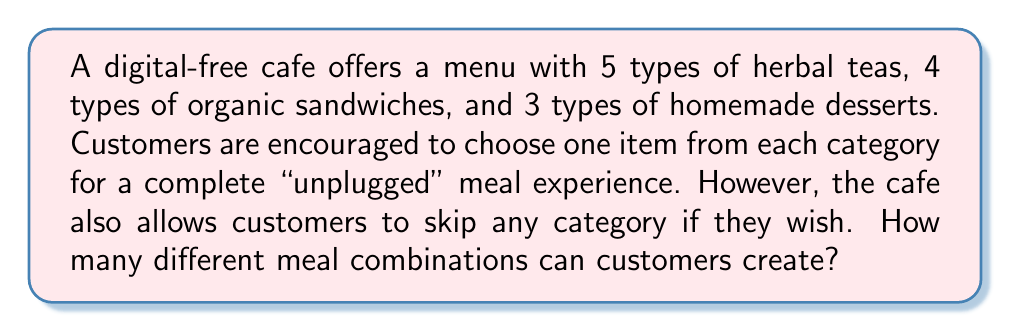What is the answer to this math problem? Let's approach this step-by-step:

1) First, we need to consider the options for each category:
   - Herbal teas: 5 options
   - Organic sandwiches: 4 options
   - Homemade desserts: 3 options

2) For each category, customers have the option to either choose an item or skip it. This means we need to add 1 to each category's count to represent the "skip" option:
   - Herbal teas: 5 + 1 = 6 options (including skip)
   - Organic sandwiches: 4 + 1 = 5 options (including skip)
   - Homemade desserts: 3 + 1 = 4 options (including skip)

3) Now, we can use the multiplication principle. The total number of combinations is the product of the number of options for each category:

   $$ \text{Total combinations} = 6 \times 5 \times 4 $$

4) Calculate:
   $$ 6 \times 5 \times 4 = 120 $$

5) However, we need to subtract 1 from this total. Why? Because the combination where all categories are skipped (no tea, no sandwich, no dessert) is not a valid meal combination.

Therefore, the final number of valid meal combinations is:

$$ 120 - 1 = 119 $$
Answer: 119 different meal combinations 